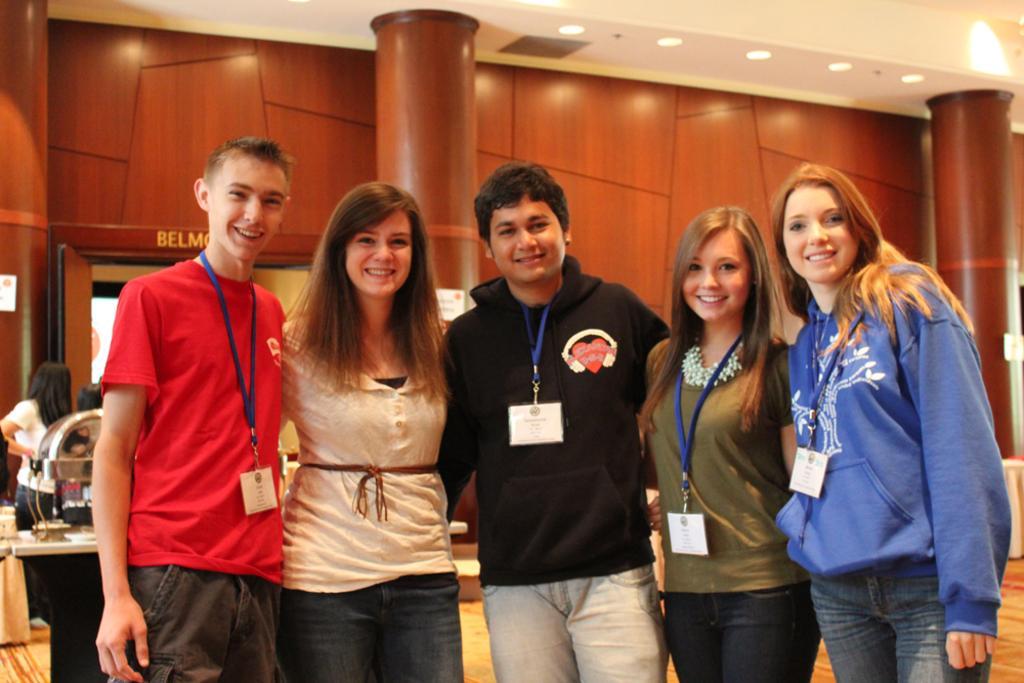In one or two sentences, can you explain what this image depicts? In the foreground of the picture I can see five persons and there is a smile on their faces. I can see a woman on the left side. It is looking like a table on the left side. In the background, I can see the pillars. There is a lighting arrangement on the roof. 